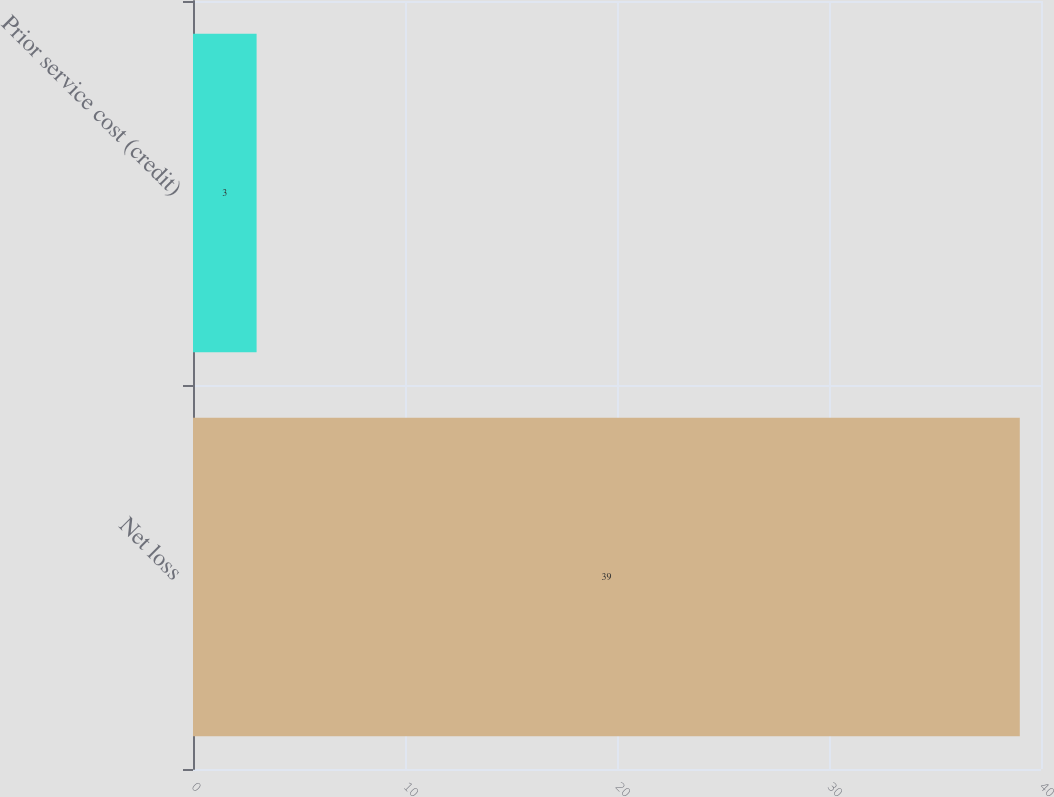Convert chart to OTSL. <chart><loc_0><loc_0><loc_500><loc_500><bar_chart><fcel>Net loss<fcel>Prior service cost (credit)<nl><fcel>39<fcel>3<nl></chart> 